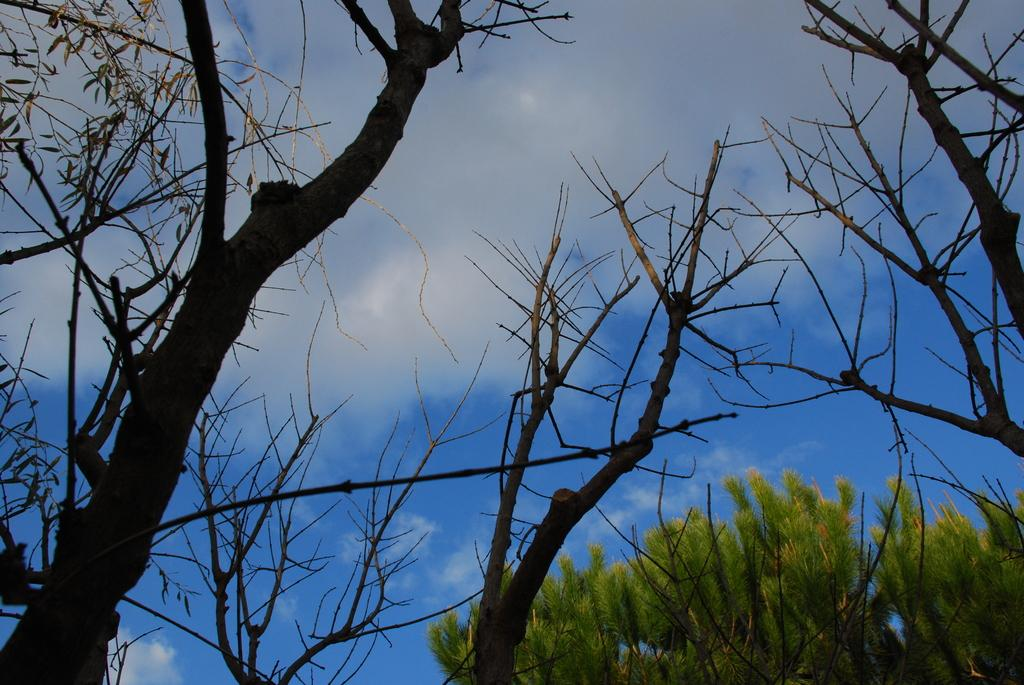What type of vegetation can be seen in the image? There are many trees in the image. What is visible at the top of the image? The sky is visible at the top of the image and appears clear. What type of soup is being prepared in the image? There is no soup or any indication of food preparation in the image. 